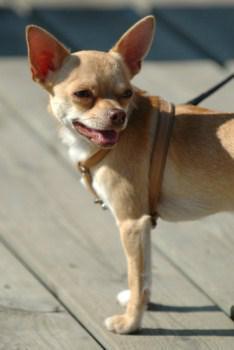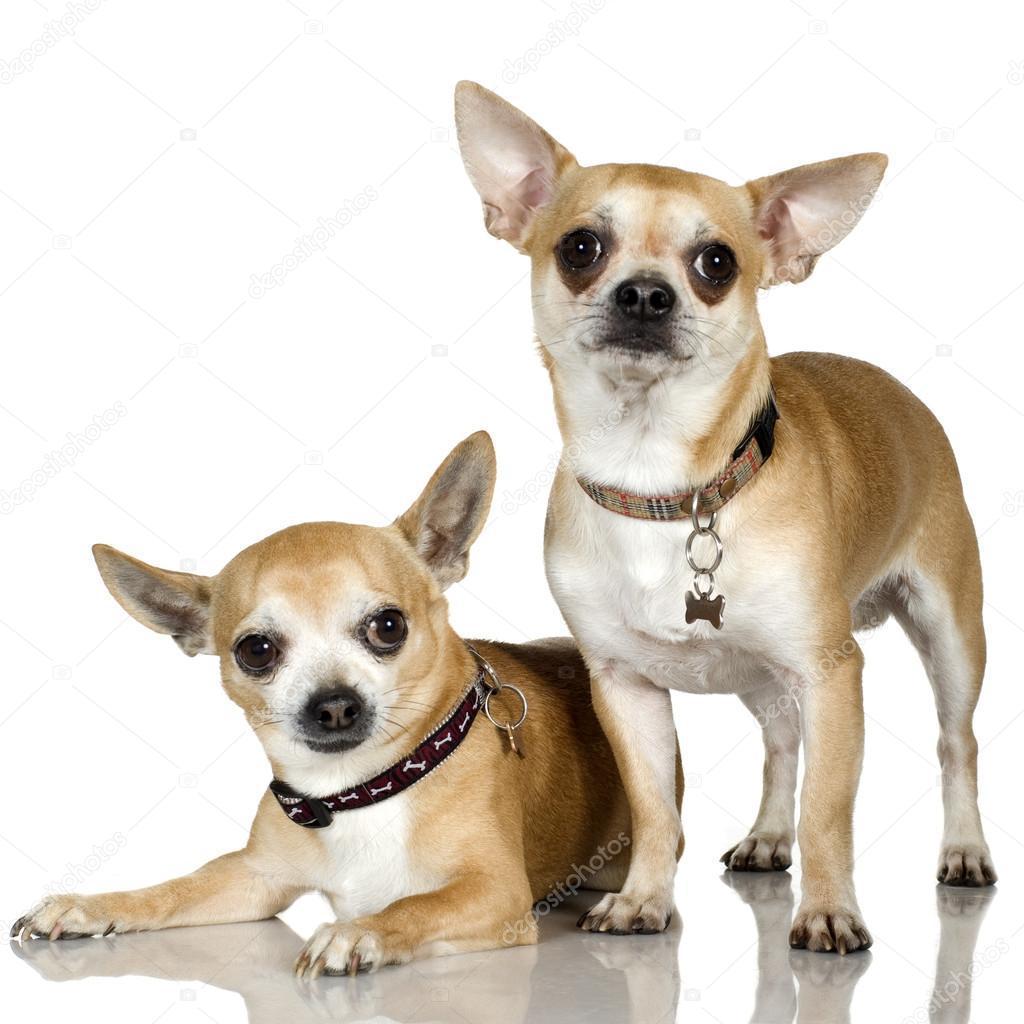The first image is the image on the left, the second image is the image on the right. Assess this claim about the two images: "There are more dogs in the image on the right.". Correct or not? Answer yes or no. Yes. The first image is the image on the left, the second image is the image on the right. Examine the images to the left and right. Is the description "All chihuahuas pictured are wearing at least collars, and each image includes at least one standing chihuahua." accurate? Answer yes or no. Yes. 